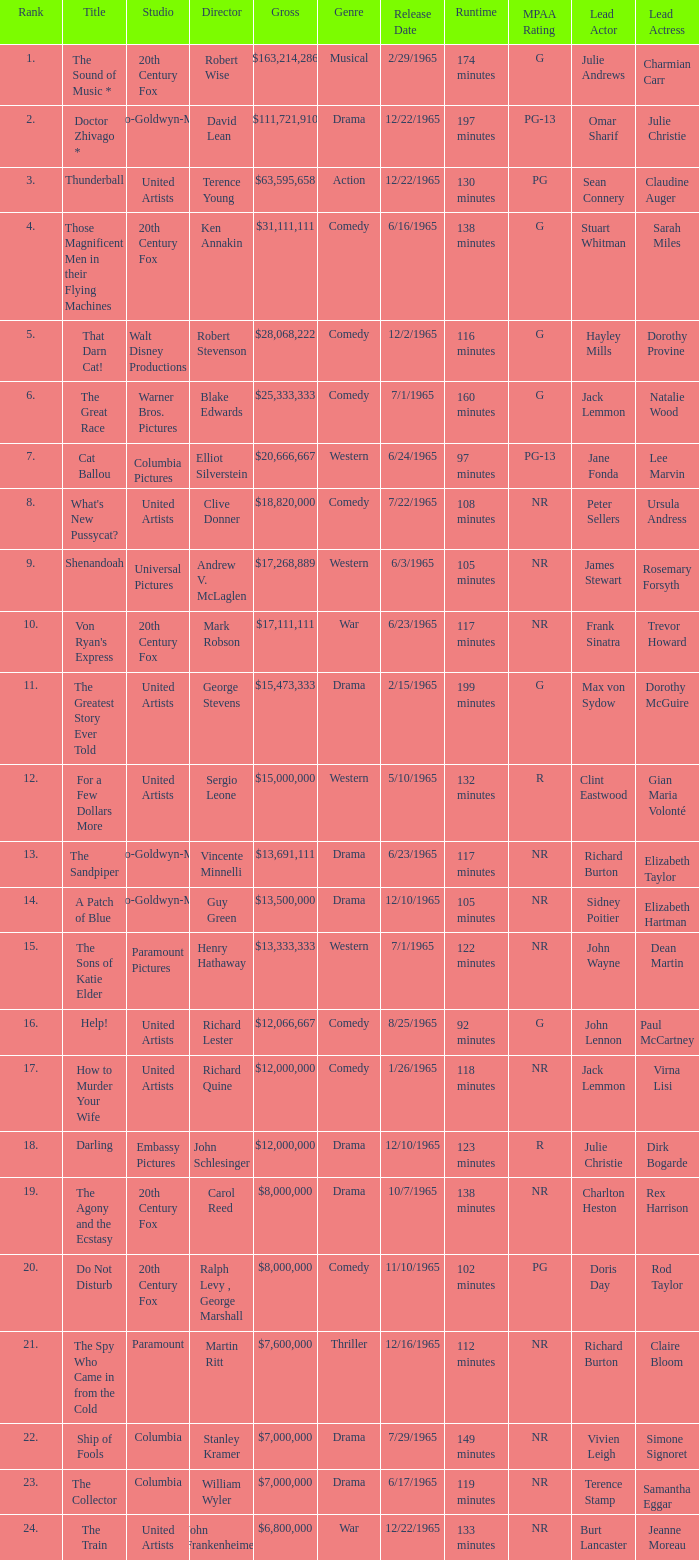What is Title, when Studio is "Embassy Pictures"? Darling. 